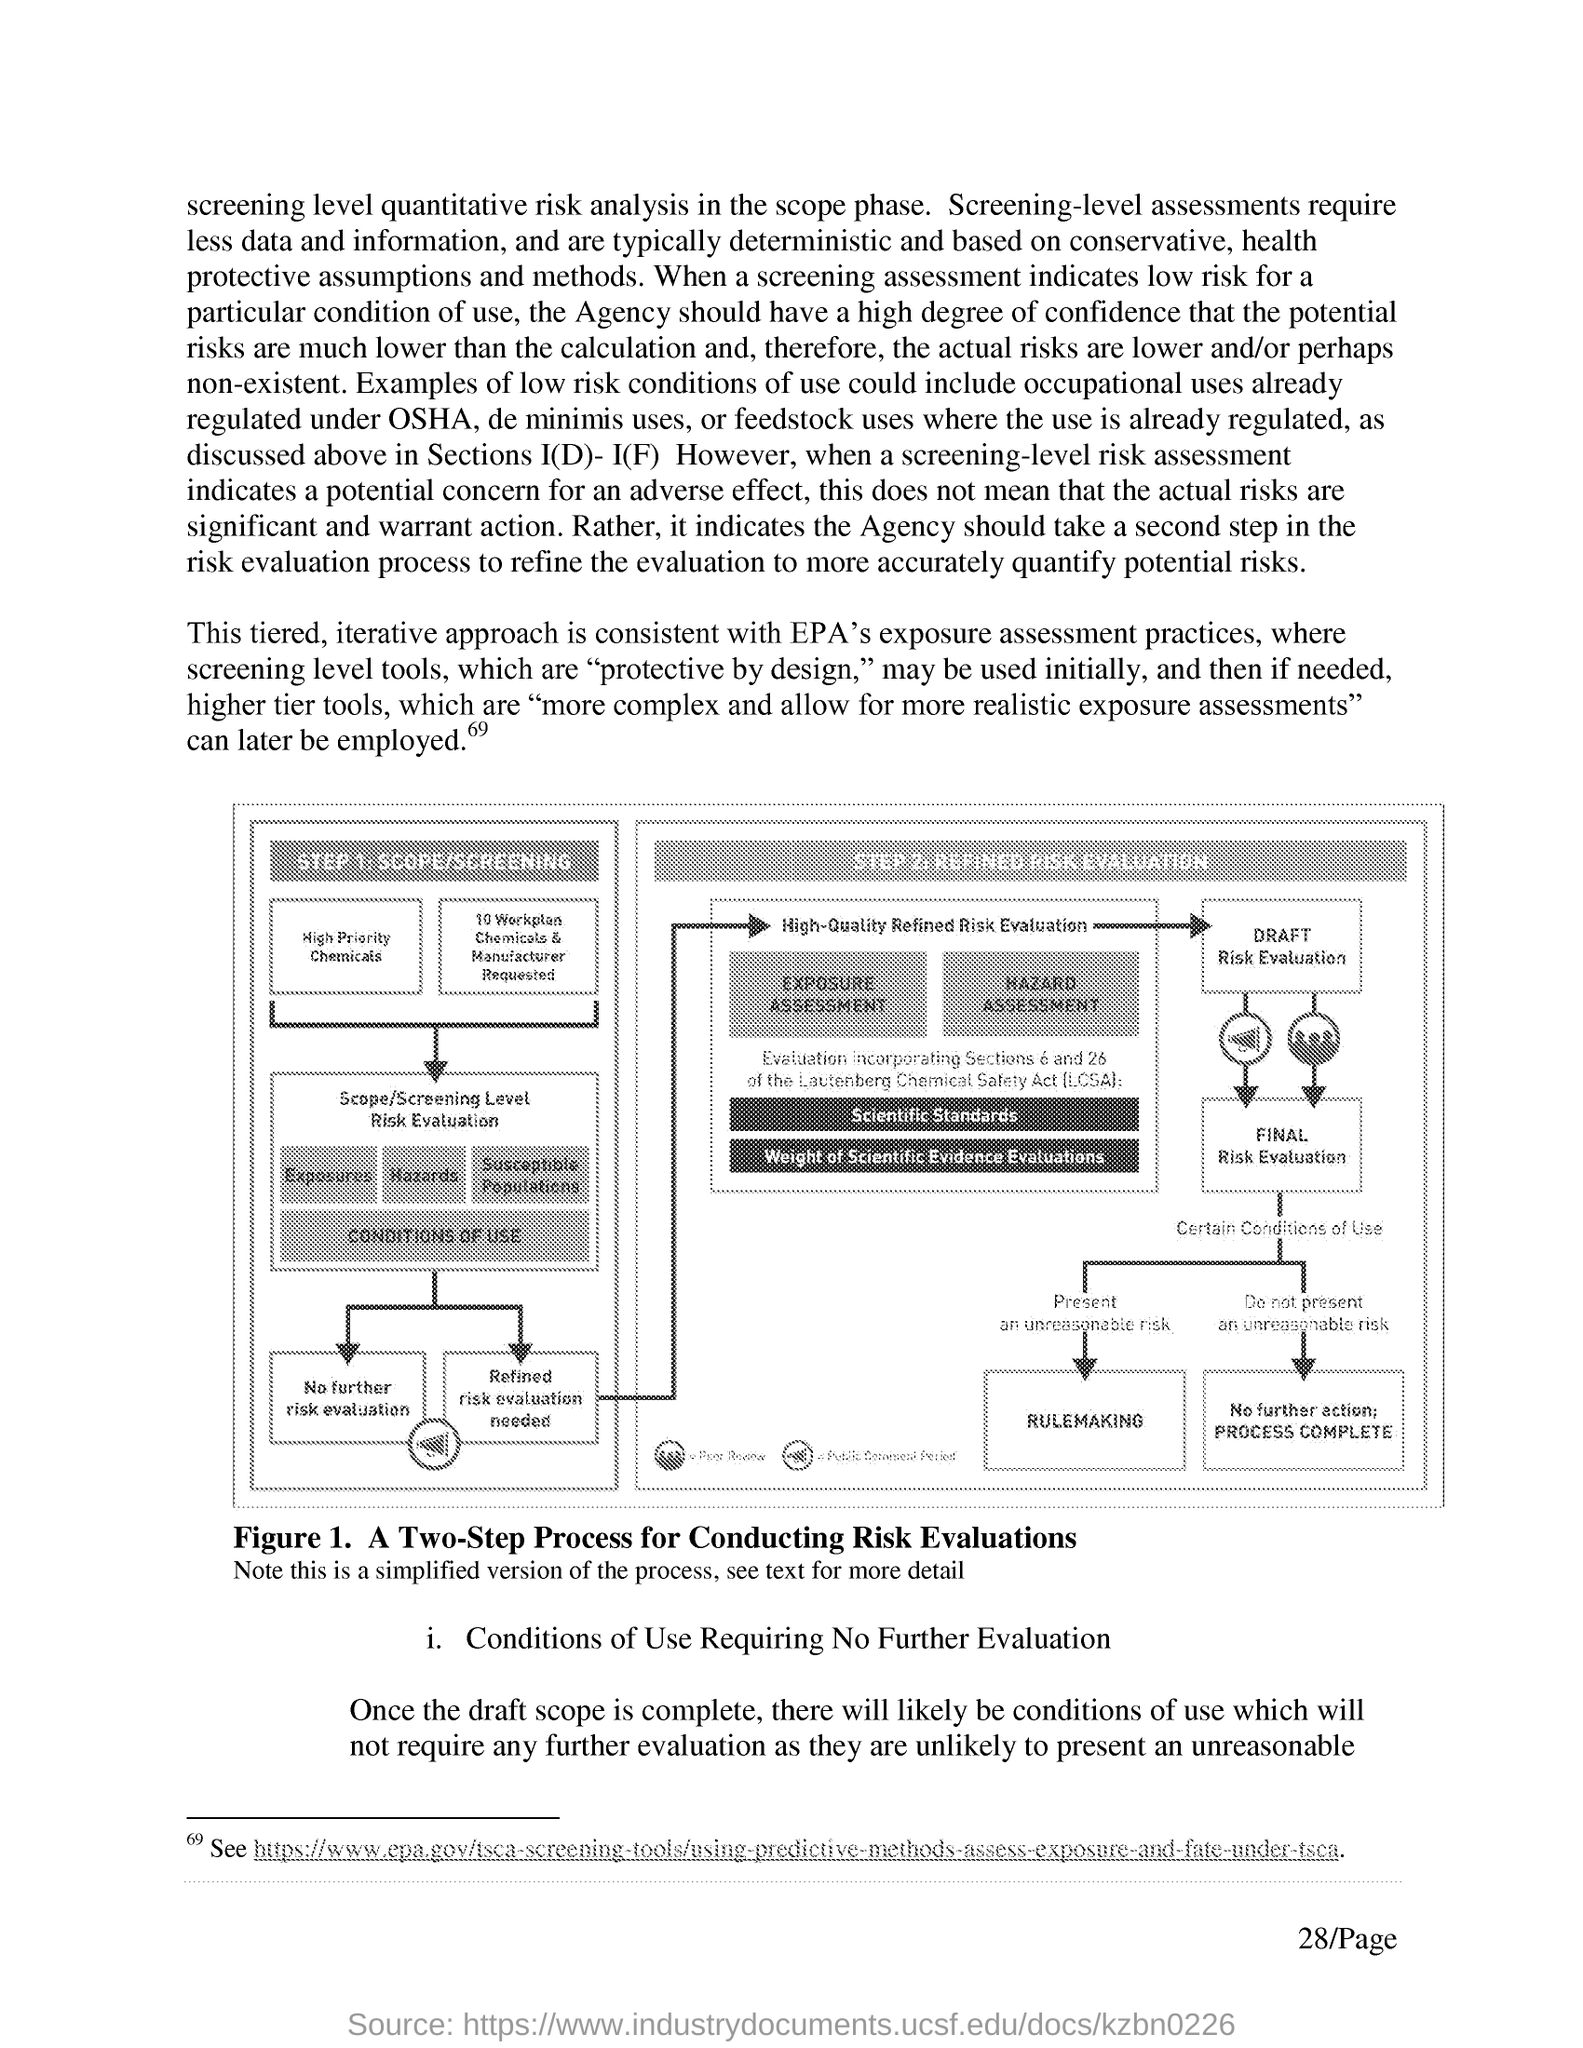Highlight a few significant elements in this photo. Figure 1 in this document depicts a two-step process for conducting risk evaluations. The step 2 for conducting a risk evaluation is refined risk evaluation, which involves further assessing the likelihood and consequences of each risk, as well as determining the priority of each risk based on its potential impact on the project. The first step in conducting a risk evaluation is scope/screening. 